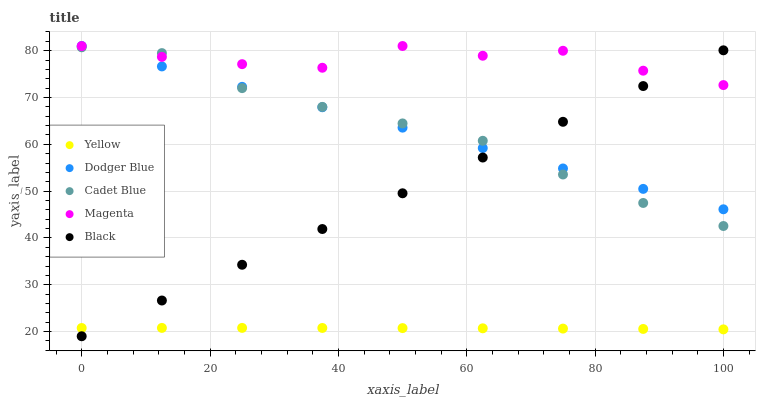Does Yellow have the minimum area under the curve?
Answer yes or no. Yes. Does Magenta have the maximum area under the curve?
Answer yes or no. Yes. Does Cadet Blue have the minimum area under the curve?
Answer yes or no. No. Does Cadet Blue have the maximum area under the curve?
Answer yes or no. No. Is Black the smoothest?
Answer yes or no. Yes. Is Magenta the roughest?
Answer yes or no. Yes. Is Cadet Blue the smoothest?
Answer yes or no. No. Is Cadet Blue the roughest?
Answer yes or no. No. Does Black have the lowest value?
Answer yes or no. Yes. Does Cadet Blue have the lowest value?
Answer yes or no. No. Does Dodger Blue have the highest value?
Answer yes or no. Yes. Does Cadet Blue have the highest value?
Answer yes or no. No. Is Yellow less than Dodger Blue?
Answer yes or no. Yes. Is Magenta greater than Yellow?
Answer yes or no. Yes. Does Cadet Blue intersect Dodger Blue?
Answer yes or no. Yes. Is Cadet Blue less than Dodger Blue?
Answer yes or no. No. Is Cadet Blue greater than Dodger Blue?
Answer yes or no. No. Does Yellow intersect Dodger Blue?
Answer yes or no. No. 